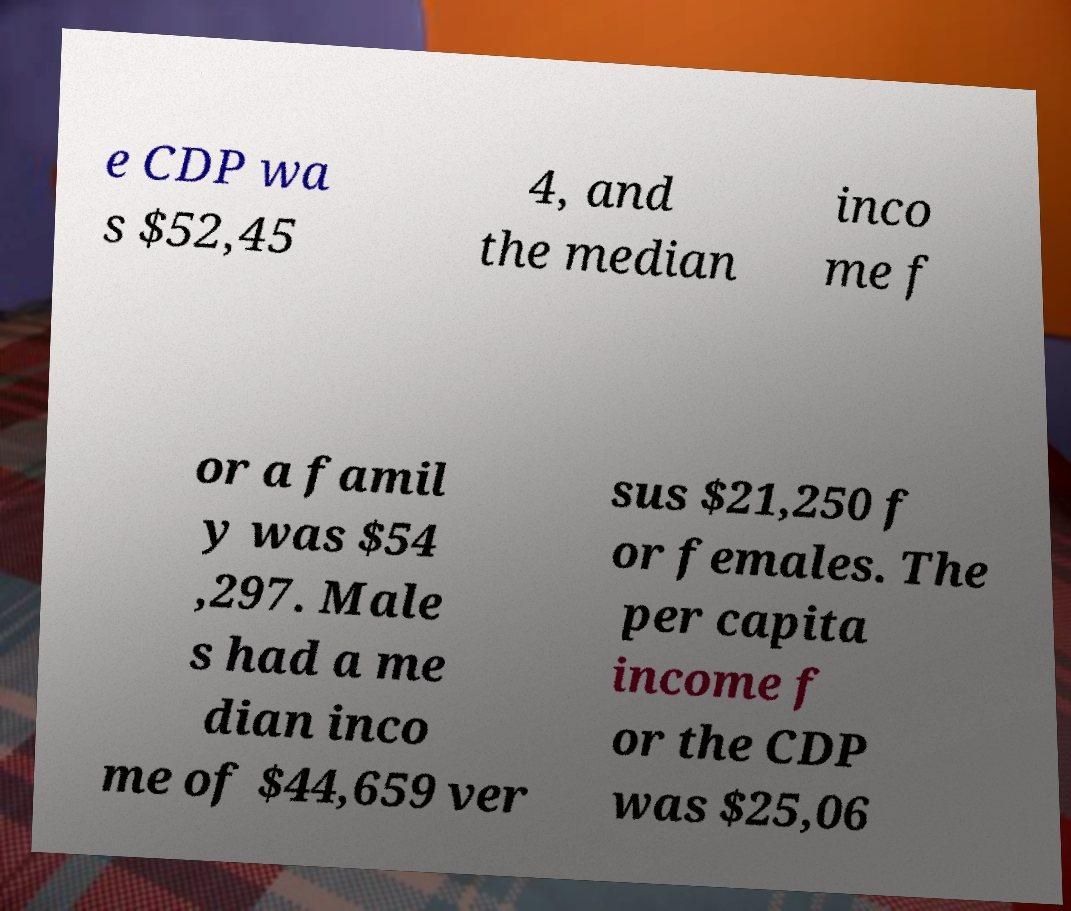There's text embedded in this image that I need extracted. Can you transcribe it verbatim? e CDP wa s $52,45 4, and the median inco me f or a famil y was $54 ,297. Male s had a me dian inco me of $44,659 ver sus $21,250 f or females. The per capita income f or the CDP was $25,06 